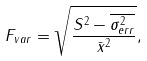Convert formula to latex. <formula><loc_0><loc_0><loc_500><loc_500>F _ { v a r } = \sqrt { \frac { S ^ { 2 } - \overline { \sigma _ { e r r } ^ { 2 } } } { { \bar { x } ^ { 2 } } } } ,</formula> 